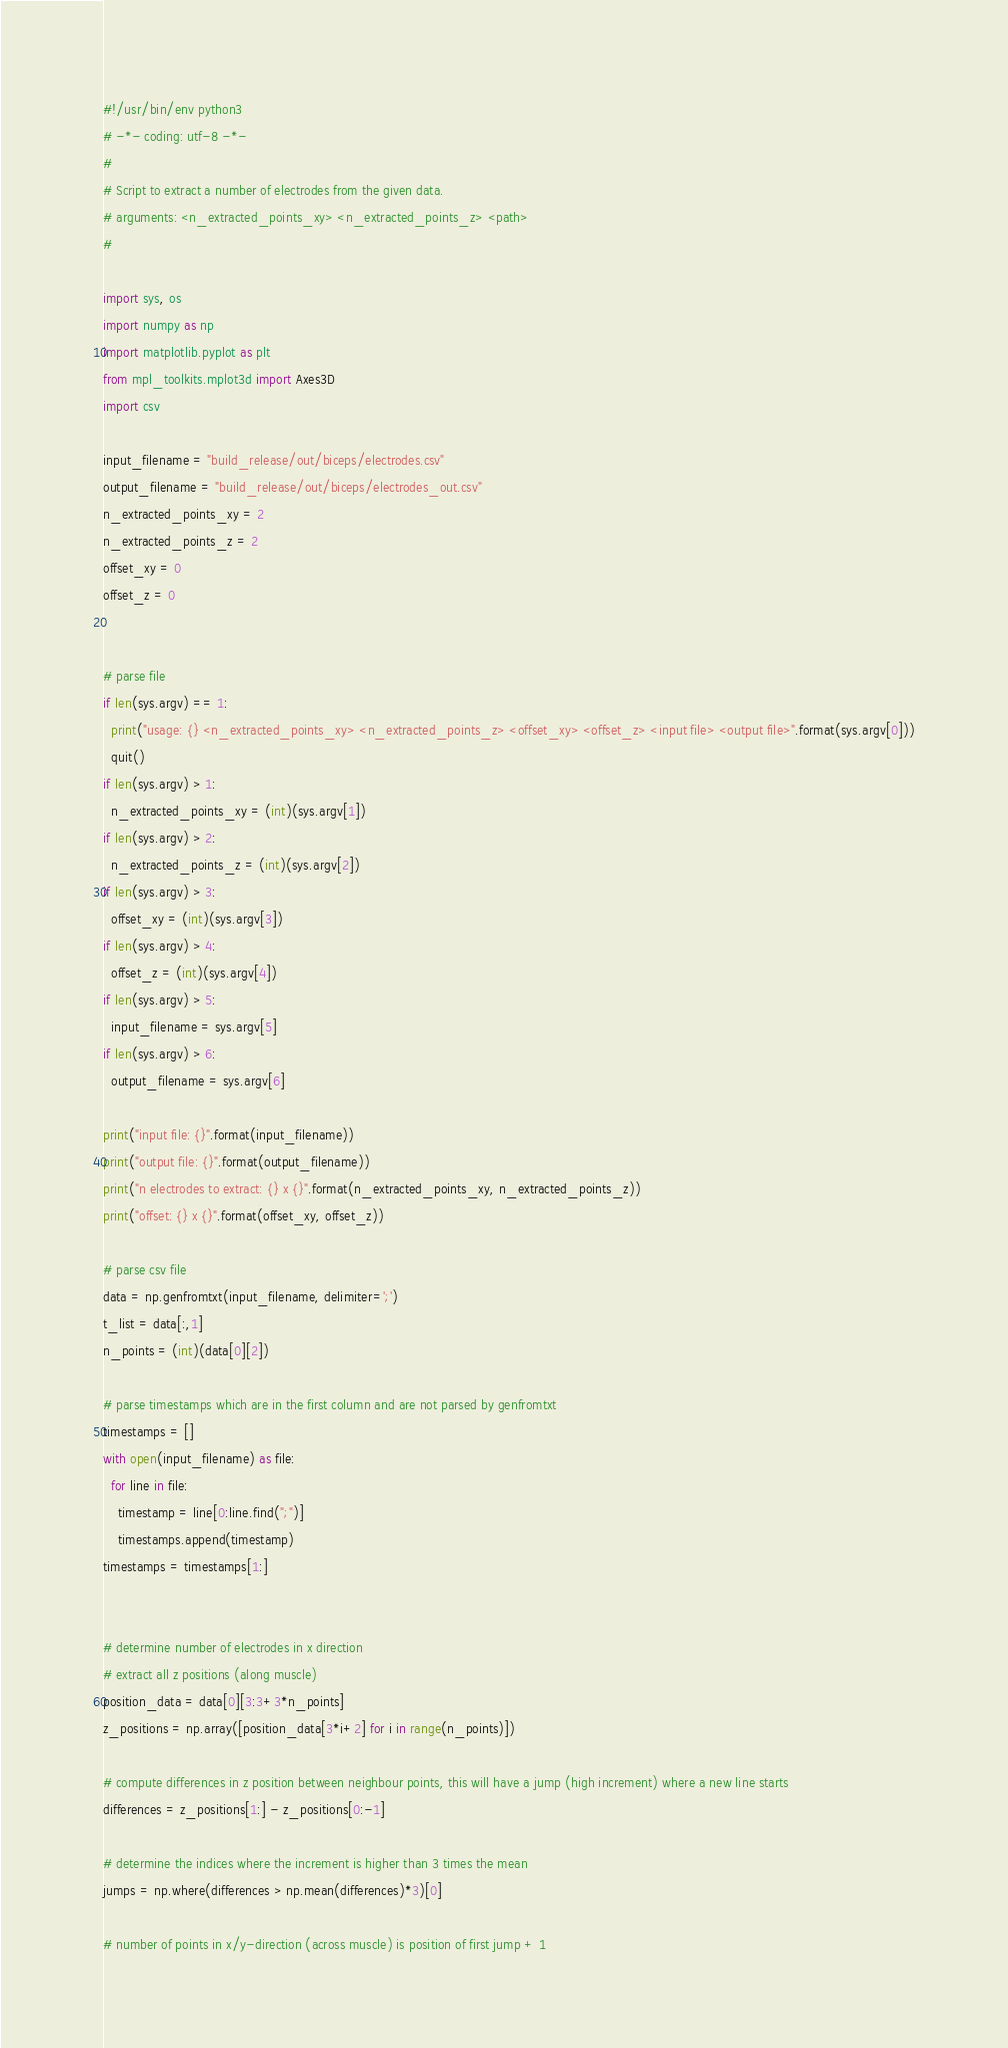<code> <loc_0><loc_0><loc_500><loc_500><_Python_>#!/usr/bin/env python3
# -*- coding: utf-8 -*-
#
# Script to extract a number of electrodes from the given data.
# arguments: <n_extracted_points_xy> <n_extracted_points_z> <path>
#

import sys, os
import numpy as np
import matplotlib.pyplot as plt
from mpl_toolkits.mplot3d import Axes3D
import csv

input_filename = "build_release/out/biceps/electrodes.csv"
output_filename = "build_release/out/biceps/electrodes_out.csv"
n_extracted_points_xy = 2
n_extracted_points_z = 2
offset_xy = 0
offset_z = 0


# parse file
if len(sys.argv) == 1:
  print("usage: {} <n_extracted_points_xy> <n_extracted_points_z> <offset_xy> <offset_z> <input file> <output file>".format(sys.argv[0]))
  quit()
if len(sys.argv) > 1:
  n_extracted_points_xy = (int)(sys.argv[1])
if len(sys.argv) > 2:
  n_extracted_points_z = (int)(sys.argv[2])
if len(sys.argv) > 3:
  offset_xy = (int)(sys.argv[3])
if len(sys.argv) > 4:
  offset_z = (int)(sys.argv[4])
if len(sys.argv) > 5:
  input_filename = sys.argv[5]
if len(sys.argv) > 6:
  output_filename = sys.argv[6]
  
print("input file: {}".format(input_filename))
print("output file: {}".format(output_filename))
print("n electrodes to extract: {} x {}".format(n_extracted_points_xy, n_extracted_points_z))
print("offset: {} x {}".format(offset_xy, offset_z))

# parse csv file
data = np.genfromtxt(input_filename, delimiter=';')
t_list = data[:,1]
n_points = (int)(data[0][2])

# parse timestamps which are in the first column and are not parsed by genfromtxt
timestamps = []
with open(input_filename) as file:
  for line in file:
    timestamp = line[0:line.find(";")]
    timestamps.append(timestamp)
timestamps = timestamps[1:]
  

# determine number of electrodes in x direction
# extract all z positions (along muscle)
position_data = data[0][3:3+3*n_points]
z_positions = np.array([position_data[3*i+2] for i in range(n_points)])

# compute differences in z position between neighbour points, this will have a jump (high increment) where a new line starts
differences = z_positions[1:] - z_positions[0:-1]

# determine the indices where the increment is higher than 3 times the mean 
jumps = np.where(differences > np.mean(differences)*3)[0]

# number of points in x/y-direction (across muscle) is position of first jump + 1</code> 